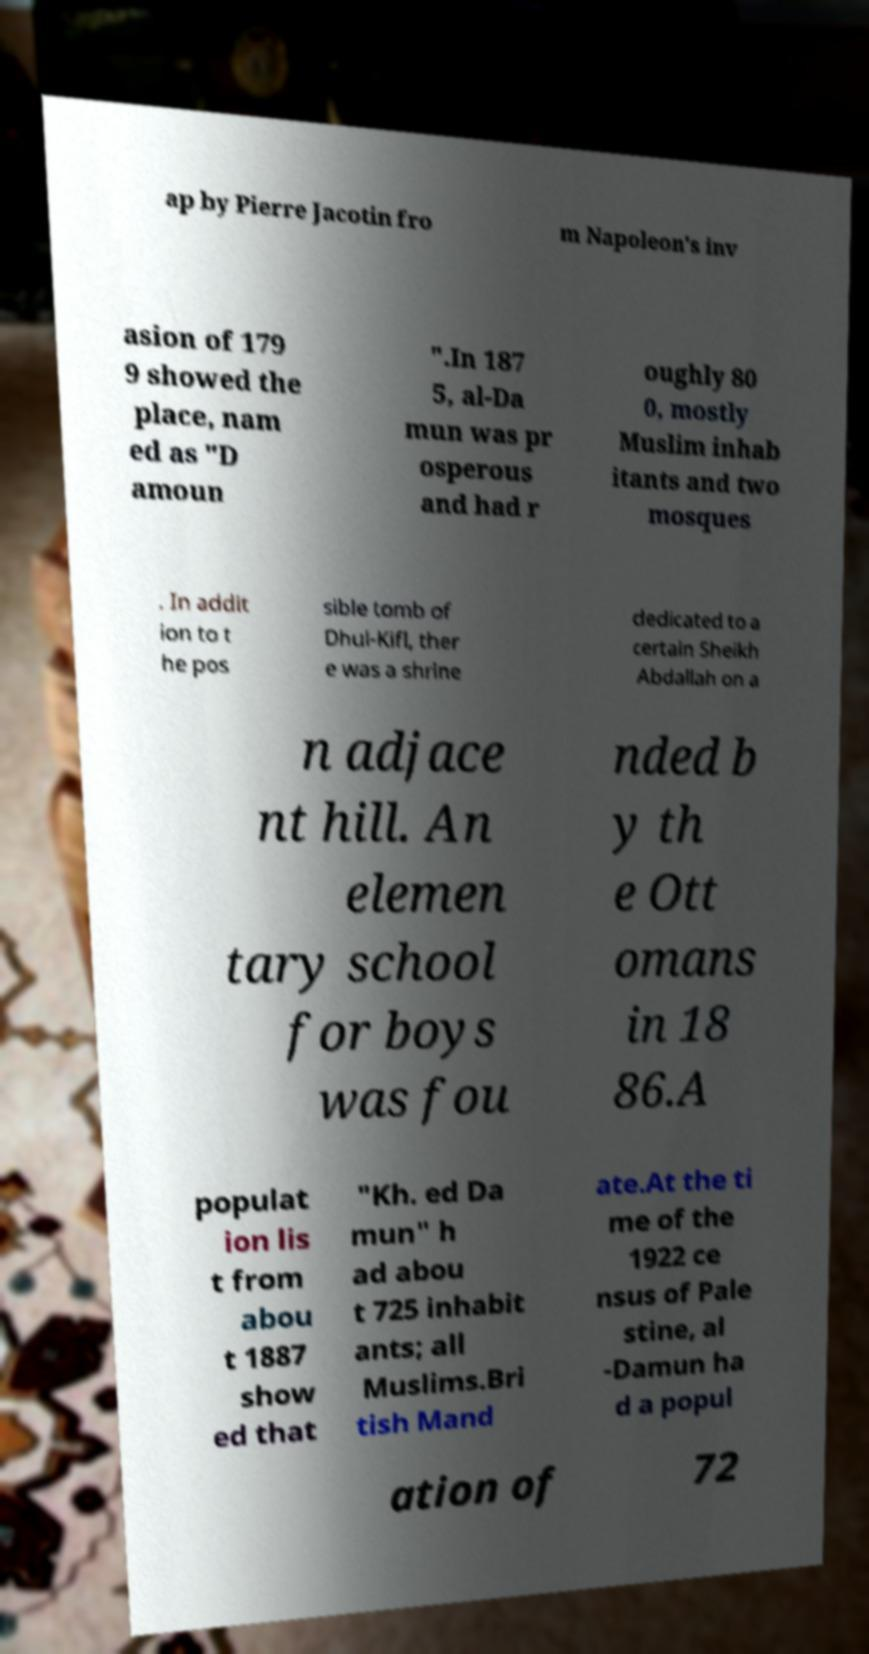Please read and relay the text visible in this image. What does it say? ap by Pierre Jacotin fro m Napoleon's inv asion of 179 9 showed the place, nam ed as "D amoun ".In 187 5, al-Da mun was pr osperous and had r oughly 80 0, mostly Muslim inhab itants and two mosques . In addit ion to t he pos sible tomb of Dhul-Kifl, ther e was a shrine dedicated to a certain Sheikh Abdallah on a n adjace nt hill. An elemen tary school for boys was fou nded b y th e Ott omans in 18 86.A populat ion lis t from abou t 1887 show ed that "Kh. ed Da mun" h ad abou t 725 inhabit ants; all Muslims.Bri tish Mand ate.At the ti me of the 1922 ce nsus of Pale stine, al -Damun ha d a popul ation of 72 